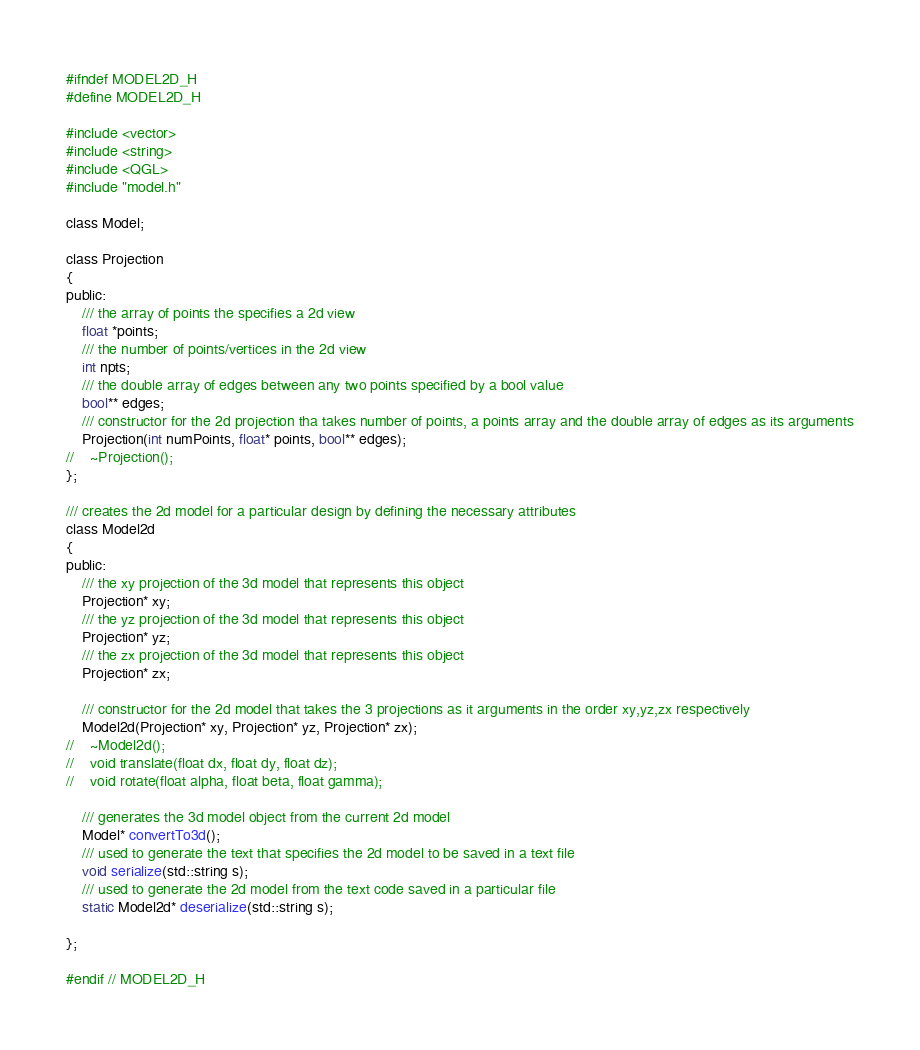<code> <loc_0><loc_0><loc_500><loc_500><_C_>#ifndef MODEL2D_H
#define MODEL2D_H

#include <vector>
#include <string>
#include <QGL>
#include "model.h"

class Model;

class Projection
{
public:
    /// the array of points the specifies a 2d view
    float *points;
    /// the number of points/vertices in the 2d view
    int npts;
    /// the double array of edges between any two points specified by a bool value
    bool** edges;
    /// constructor for the 2d projection tha takes number of points, a points array and the double array of edges as its arguments
    Projection(int numPoints, float* points, bool** edges);
//    ~Projection();
};

/// creates the 2d model for a particular design by defining the necessary attributes
class Model2d
{
public:
    /// the xy projection of the 3d model that represents this object
    Projection* xy;
    /// the yz projection of the 3d model that represents this object
    Projection* yz;
    /// the zx projection of the 3d model that represents this object
    Projection* zx;

    /// constructor for the 2d model that takes the 3 projections as it arguments in the order xy,yz,zx respectively
    Model2d(Projection* xy, Projection* yz, Projection* zx);
//    ~Model2d();
//    void translate(float dx, float dy, float dz);
//    void rotate(float alpha, float beta, float gamma);

    /// generates the 3d model object from the current 2d model
    Model* convertTo3d();
    /// used to generate the text that specifies the 2d model to be saved in a text file
    void serialize(std::string s);
    /// used to generate the 2d model from the text code saved in a particular file
    static Model2d* deserialize(std::string s);

};

#endif // MODEL2D_H
</code> 